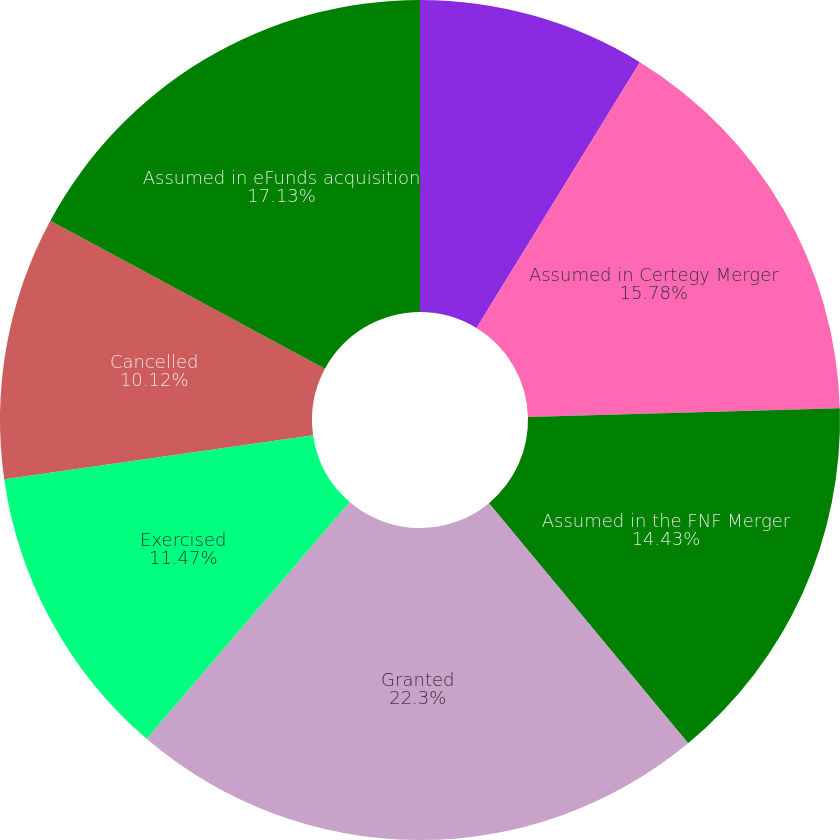Convert chart to OTSL. <chart><loc_0><loc_0><loc_500><loc_500><pie_chart><fcel>Balance December 31 2005<fcel>Assumed in Certegy Merger<fcel>Assumed in the FNF Merger<fcel>Granted<fcel>Exercised<fcel>Cancelled<fcel>Assumed in eFunds acquisition<nl><fcel>8.77%<fcel>15.78%<fcel>14.43%<fcel>22.3%<fcel>11.47%<fcel>10.12%<fcel>17.13%<nl></chart> 